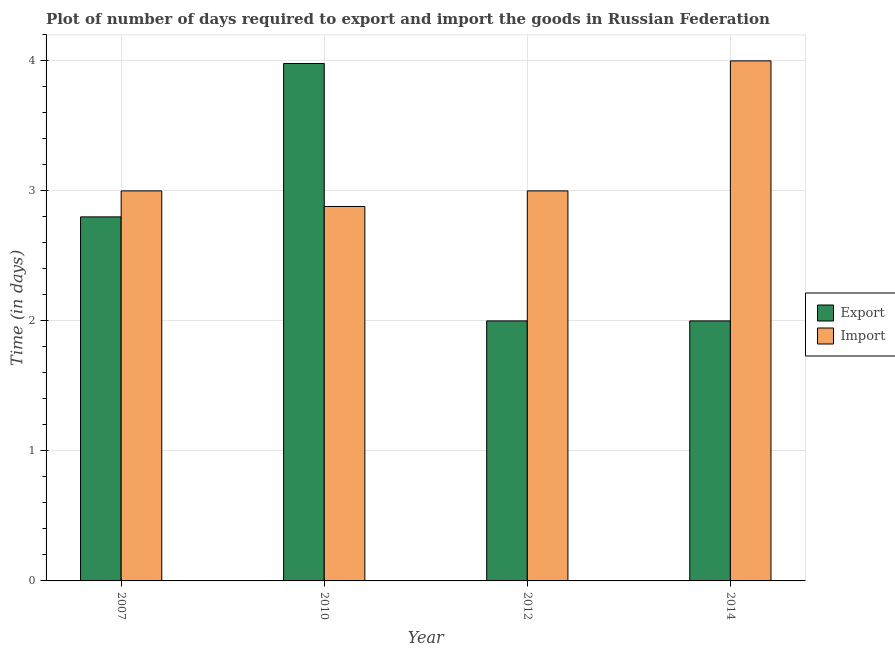How many different coloured bars are there?
Your answer should be compact. 2. How many groups of bars are there?
Your answer should be compact. 4. Are the number of bars on each tick of the X-axis equal?
Keep it short and to the point. Yes. In how many cases, is the number of bars for a given year not equal to the number of legend labels?
Give a very brief answer. 0. What is the time required to import in 2010?
Ensure brevity in your answer.  2.88. Across all years, what is the maximum time required to import?
Give a very brief answer. 4. Across all years, what is the minimum time required to export?
Offer a very short reply. 2. In which year was the time required to export maximum?
Give a very brief answer. 2010. In which year was the time required to export minimum?
Offer a very short reply. 2012. What is the total time required to import in the graph?
Offer a terse response. 12.88. What is the difference between the time required to import in 2012 and that in 2014?
Provide a short and direct response. -1. What is the difference between the time required to export in 2014 and the time required to import in 2010?
Your response must be concise. -1.98. What is the average time required to import per year?
Your answer should be very brief. 3.22. In the year 2014, what is the difference between the time required to import and time required to export?
Give a very brief answer. 0. What is the ratio of the time required to import in 2007 to that in 2012?
Provide a succinct answer. 1. Is the difference between the time required to export in 2007 and 2014 greater than the difference between the time required to import in 2007 and 2014?
Give a very brief answer. No. What is the difference between the highest and the second highest time required to export?
Ensure brevity in your answer.  1.18. What is the difference between the highest and the lowest time required to import?
Keep it short and to the point. 1.12. In how many years, is the time required to import greater than the average time required to import taken over all years?
Make the answer very short. 1. What does the 2nd bar from the left in 2014 represents?
Make the answer very short. Import. What does the 2nd bar from the right in 2014 represents?
Provide a short and direct response. Export. Are all the bars in the graph horizontal?
Ensure brevity in your answer.  No. Where does the legend appear in the graph?
Your answer should be compact. Center right. What is the title of the graph?
Provide a succinct answer. Plot of number of days required to export and import the goods in Russian Federation. Does "Formally registered" appear as one of the legend labels in the graph?
Your answer should be very brief. No. What is the label or title of the Y-axis?
Keep it short and to the point. Time (in days). What is the Time (in days) in Export in 2007?
Keep it short and to the point. 2.8. What is the Time (in days) in Import in 2007?
Provide a short and direct response. 3. What is the Time (in days) of Export in 2010?
Make the answer very short. 3.98. What is the Time (in days) of Import in 2010?
Your response must be concise. 2.88. What is the Time (in days) of Import in 2012?
Your answer should be compact. 3. What is the Time (in days) in Import in 2014?
Your answer should be very brief. 4. Across all years, what is the maximum Time (in days) of Export?
Keep it short and to the point. 3.98. Across all years, what is the maximum Time (in days) of Import?
Give a very brief answer. 4. Across all years, what is the minimum Time (in days) in Export?
Give a very brief answer. 2. Across all years, what is the minimum Time (in days) of Import?
Provide a short and direct response. 2.88. What is the total Time (in days) of Export in the graph?
Offer a very short reply. 10.78. What is the total Time (in days) of Import in the graph?
Your response must be concise. 12.88. What is the difference between the Time (in days) in Export in 2007 and that in 2010?
Offer a terse response. -1.18. What is the difference between the Time (in days) in Import in 2007 and that in 2010?
Provide a succinct answer. 0.12. What is the difference between the Time (in days) of Import in 2007 and that in 2012?
Keep it short and to the point. 0. What is the difference between the Time (in days) in Export in 2007 and that in 2014?
Make the answer very short. 0.8. What is the difference between the Time (in days) in Import in 2007 and that in 2014?
Ensure brevity in your answer.  -1. What is the difference between the Time (in days) of Export in 2010 and that in 2012?
Your answer should be compact. 1.98. What is the difference between the Time (in days) of Import in 2010 and that in 2012?
Ensure brevity in your answer.  -0.12. What is the difference between the Time (in days) in Export in 2010 and that in 2014?
Give a very brief answer. 1.98. What is the difference between the Time (in days) in Import in 2010 and that in 2014?
Offer a very short reply. -1.12. What is the difference between the Time (in days) of Import in 2012 and that in 2014?
Ensure brevity in your answer.  -1. What is the difference between the Time (in days) in Export in 2007 and the Time (in days) in Import in 2010?
Your answer should be compact. -0.08. What is the difference between the Time (in days) in Export in 2007 and the Time (in days) in Import in 2012?
Your response must be concise. -0.2. What is the difference between the Time (in days) in Export in 2010 and the Time (in days) in Import in 2014?
Your answer should be very brief. -0.02. What is the difference between the Time (in days) in Export in 2012 and the Time (in days) in Import in 2014?
Your answer should be very brief. -2. What is the average Time (in days) in Export per year?
Provide a succinct answer. 2.69. What is the average Time (in days) of Import per year?
Keep it short and to the point. 3.22. In the year 2014, what is the difference between the Time (in days) of Export and Time (in days) of Import?
Your response must be concise. -2. What is the ratio of the Time (in days) of Export in 2007 to that in 2010?
Offer a very short reply. 0.7. What is the ratio of the Time (in days) in Import in 2007 to that in 2010?
Provide a short and direct response. 1.04. What is the ratio of the Time (in days) in Export in 2007 to that in 2012?
Make the answer very short. 1.4. What is the ratio of the Time (in days) in Import in 2007 to that in 2014?
Your answer should be very brief. 0.75. What is the ratio of the Time (in days) in Export in 2010 to that in 2012?
Ensure brevity in your answer.  1.99. What is the ratio of the Time (in days) in Export in 2010 to that in 2014?
Keep it short and to the point. 1.99. What is the ratio of the Time (in days) in Import in 2010 to that in 2014?
Offer a very short reply. 0.72. What is the ratio of the Time (in days) in Export in 2012 to that in 2014?
Provide a succinct answer. 1. What is the ratio of the Time (in days) in Import in 2012 to that in 2014?
Your response must be concise. 0.75. What is the difference between the highest and the second highest Time (in days) in Export?
Keep it short and to the point. 1.18. What is the difference between the highest and the lowest Time (in days) of Export?
Give a very brief answer. 1.98. What is the difference between the highest and the lowest Time (in days) in Import?
Your response must be concise. 1.12. 